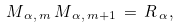<formula> <loc_0><loc_0><loc_500><loc_500>M _ { \, \alpha , \, m } \, M _ { \, \alpha , \, m + 1 } \, = \, { R } _ { \, \alpha } ,</formula> 